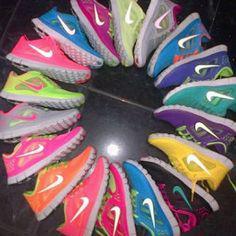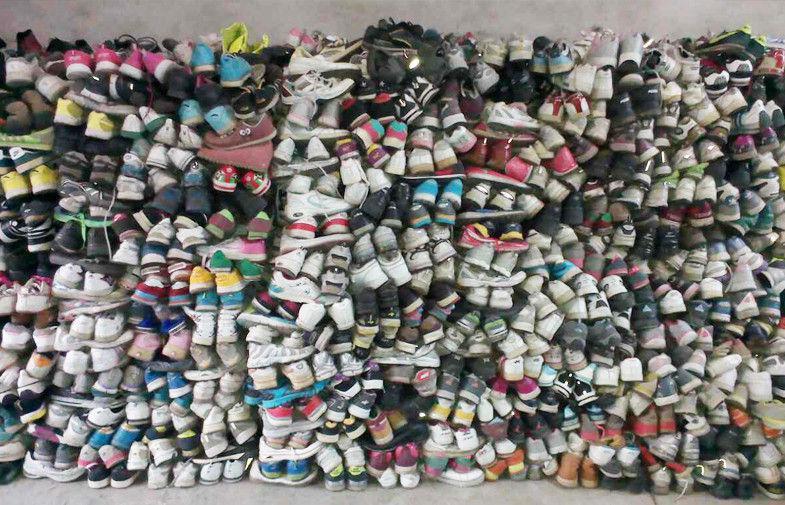The first image is the image on the left, the second image is the image on the right. Given the left and right images, does the statement "An image shows shoes lined up in rows in store displays." hold true? Answer yes or no. No. 